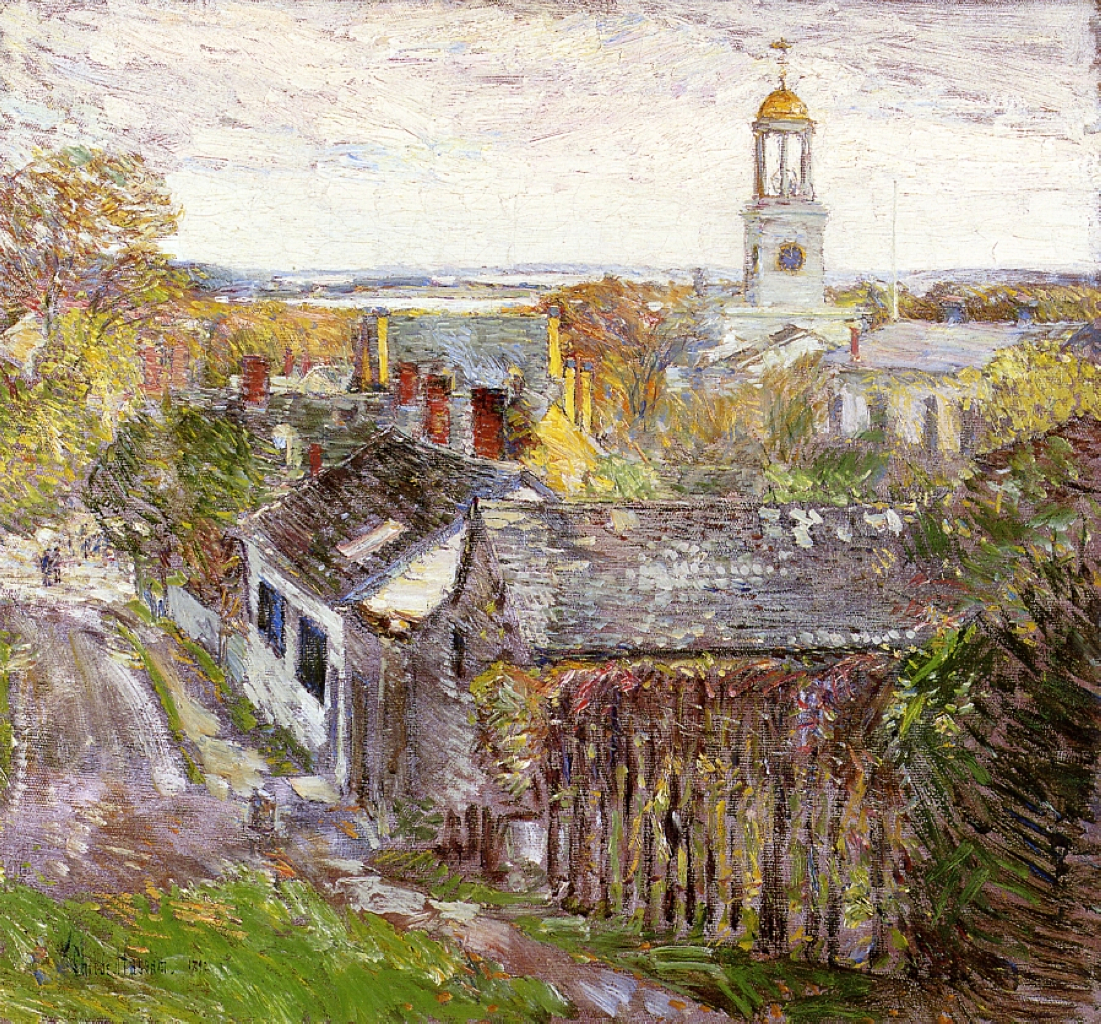What time of year does this painting depict, and how can you tell? The painting likely depicts early autumn. This inference is drawn from the palette of colors used—yellows, muted greens, and earthy oranges, which are typical of autumn foliage. Additionally, the soft, diffused light and the sparse, leaf-speckled sky contribute to a gentle yet crisp atmosphere, suggesting the transition from summer to autumn. 